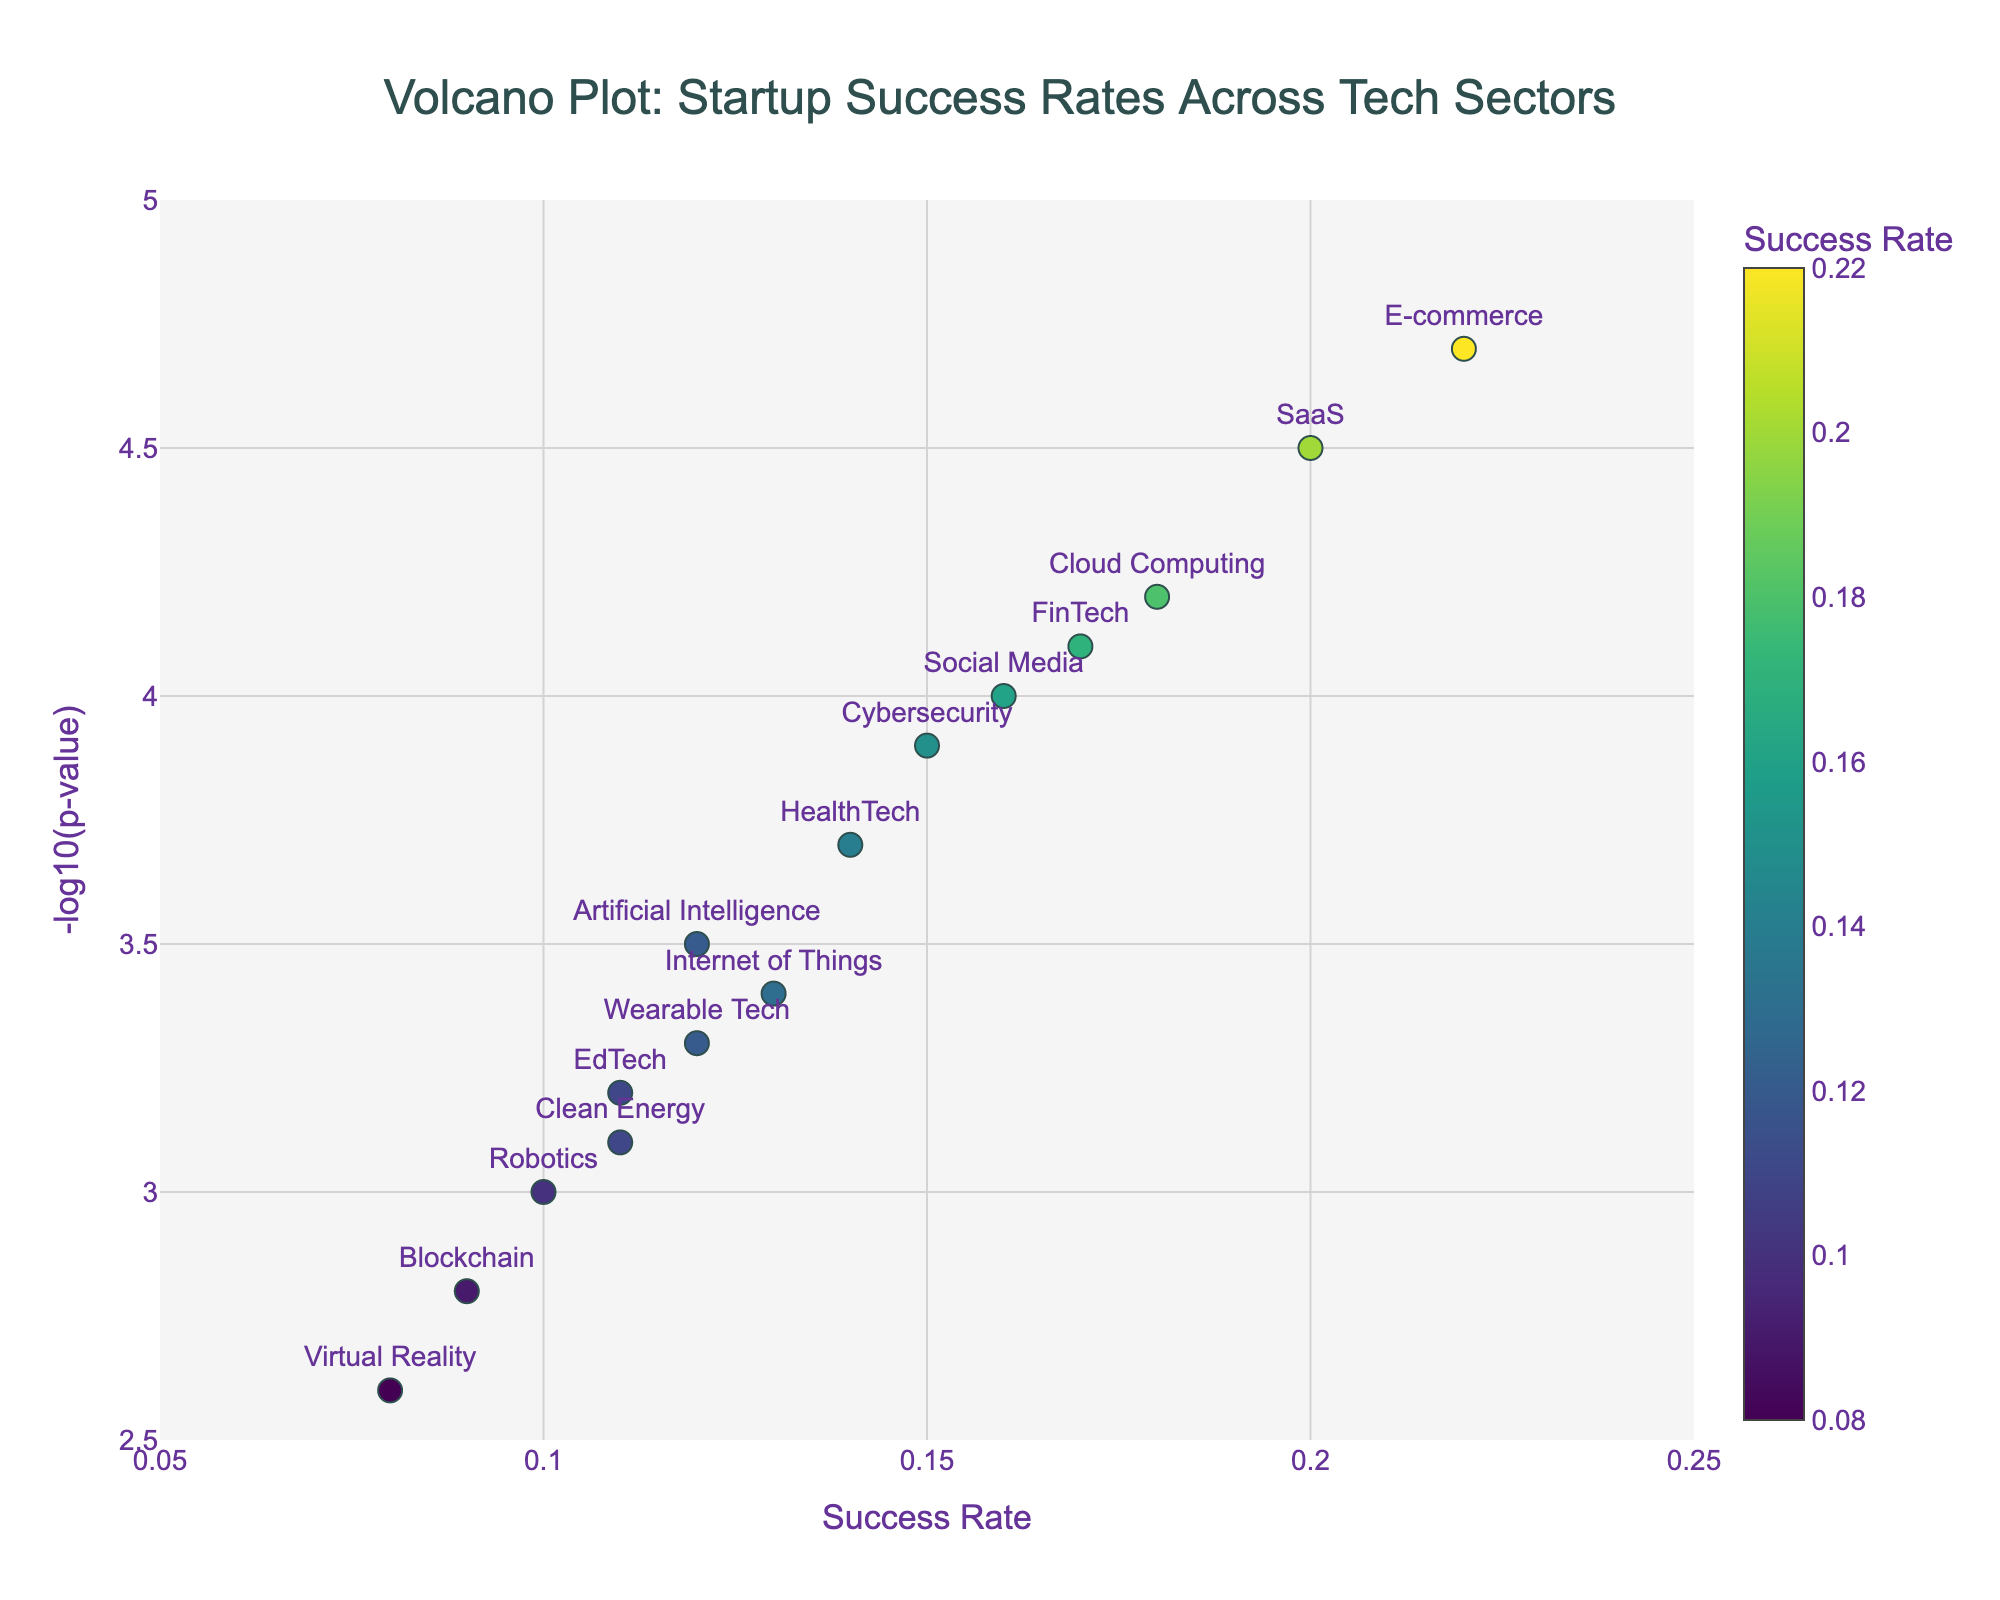What is the title of the plot? The title of the plot is usually placed prominently at the top of the figure, which can be directly read. The title provides the context and subject of the visualization.
Answer: Volcano Plot: Startup Success Rates Across Tech Sectors Which sector has the highest success rate? To find the sector with the highest success rate, look at the x-axis and find the point farthest to the right. The corresponding label will indicate the sector.
Answer: E-commerce What is the y-axis representing? The y-axis title is clearly mentioned on the figure and represents the variable being measured. In this plot, the y-axis title is "-log10(p-value)" indicating how statistical significance of the success rate is represented.
Answer: -log10(p-value) How many sectors have a success rate of 0.12? Inspect the x-axis values to find points where the success rate is 0.12. Then count these points to determine how many sectors have this success rate.
Answer: 2 Which sectors are adjacent to each other with almost equal success rates? Compare the points plotted on the x-axis and identify sectors that have visually similar x-axis values (i.e., success rates).
Answer: Cybersecurity and Social Media Which sector has the highest -log10(p-value)? Look at the y-axis and identify the point that is plotted the highest. The sector label next to this point will show the sector with the highest -log10(p-value).
Answer: E-commerce What is the relationship between the success rate of Cloud Computing and Blockchain in terms of success rate? Compare the positions of Cloud Computing and Blockchain on the x-axis. Cloud Computing is further right than Blockchain, indicating a higher success rate.
Answer: Cloud Computing has a higher success rate than Blockchain Which sectors have success rates less than 0.10? Check the x-axis values and find points to the left of the 0.10 mark. Note the corresponding sector labels for those points.
Answer: Blockchain, Virtual Reality, and Robotics What is the relationship between -log10(p-value) and the success rates across sectors? Analyze the trend by looking at the overall distribution of points in the plot. Generally, sectors with lower success rates seem to have higher -log10(p-values), indicating higher statistical significance.
Answer: Sectors with lower success rates tend to have higher -log10(p-values) Compare the success rates and -log10(p-values) for SaaS and FinTech. Locate SaaS and FinTech points on the plot. SaaS has a higher success rate on the x-axis but both have similar y-axis values (high -log10(p-values)), indicating strong statistical significance.
Answer: SaaS has a higher success rate, both have high statistical significance 